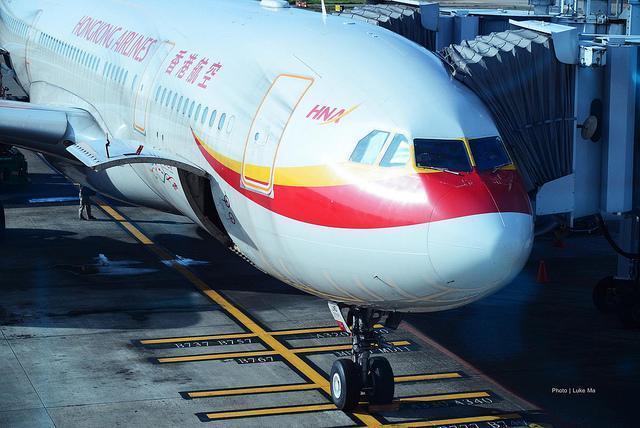How many motorcycles are there?
Give a very brief answer. 0. 